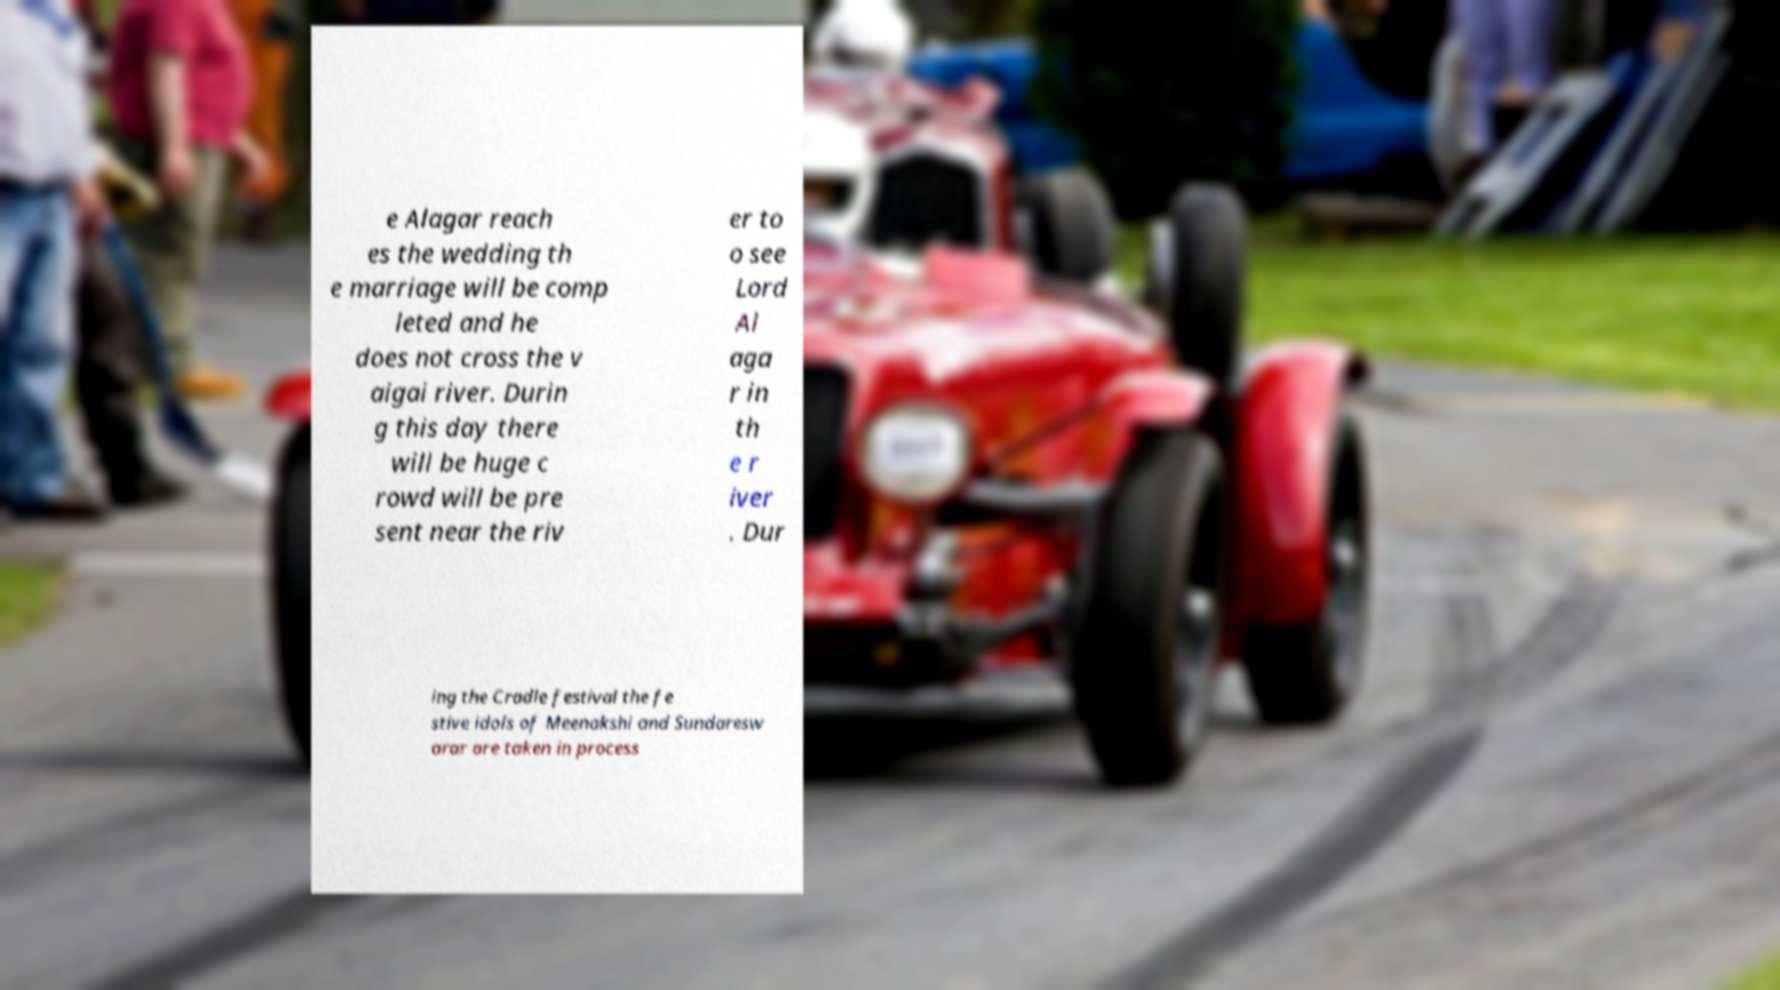There's text embedded in this image that I need extracted. Can you transcribe it verbatim? e Alagar reach es the wedding th e marriage will be comp leted and he does not cross the v aigai river. Durin g this day there will be huge c rowd will be pre sent near the riv er to o see Lord Al aga r in th e r iver . Dur ing the Cradle festival the fe stive idols of Meenakshi and Sundaresw arar are taken in process 